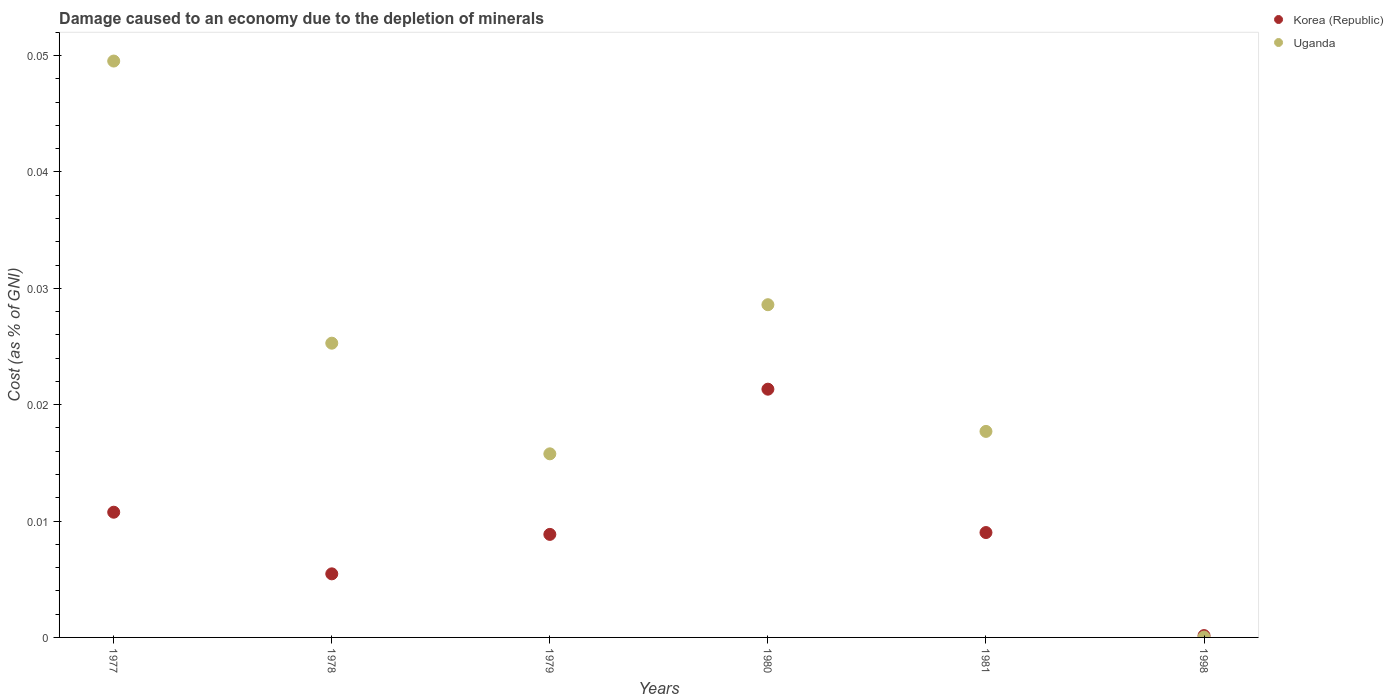What is the cost of damage caused due to the depletion of minerals in Korea (Republic) in 1979?
Offer a terse response. 0.01. Across all years, what is the maximum cost of damage caused due to the depletion of minerals in Uganda?
Your answer should be very brief. 0.05. Across all years, what is the minimum cost of damage caused due to the depletion of minerals in Korea (Republic)?
Make the answer very short. 0. In which year was the cost of damage caused due to the depletion of minerals in Uganda maximum?
Offer a terse response. 1977. What is the total cost of damage caused due to the depletion of minerals in Korea (Republic) in the graph?
Provide a short and direct response. 0.06. What is the difference between the cost of damage caused due to the depletion of minerals in Uganda in 1978 and that in 1979?
Your answer should be compact. 0.01. What is the difference between the cost of damage caused due to the depletion of minerals in Korea (Republic) in 1979 and the cost of damage caused due to the depletion of minerals in Uganda in 1977?
Your response must be concise. -0.04. What is the average cost of damage caused due to the depletion of minerals in Korea (Republic) per year?
Offer a very short reply. 0.01. In the year 1978, what is the difference between the cost of damage caused due to the depletion of minerals in Uganda and cost of damage caused due to the depletion of minerals in Korea (Republic)?
Ensure brevity in your answer.  0.02. What is the ratio of the cost of damage caused due to the depletion of minerals in Korea (Republic) in 1977 to that in 1998?
Provide a short and direct response. 67.77. Is the cost of damage caused due to the depletion of minerals in Uganda in 1981 less than that in 1998?
Make the answer very short. No. Is the difference between the cost of damage caused due to the depletion of minerals in Uganda in 1977 and 1980 greater than the difference between the cost of damage caused due to the depletion of minerals in Korea (Republic) in 1977 and 1980?
Your answer should be compact. Yes. What is the difference between the highest and the second highest cost of damage caused due to the depletion of minerals in Korea (Republic)?
Provide a succinct answer. 0.01. What is the difference between the highest and the lowest cost of damage caused due to the depletion of minerals in Korea (Republic)?
Your response must be concise. 0.02. In how many years, is the cost of damage caused due to the depletion of minerals in Korea (Republic) greater than the average cost of damage caused due to the depletion of minerals in Korea (Republic) taken over all years?
Provide a succinct answer. 2. Does the cost of damage caused due to the depletion of minerals in Korea (Republic) monotonically increase over the years?
Provide a succinct answer. No. Is the cost of damage caused due to the depletion of minerals in Uganda strictly greater than the cost of damage caused due to the depletion of minerals in Korea (Republic) over the years?
Your answer should be compact. No. How many dotlines are there?
Keep it short and to the point. 2. What is the difference between two consecutive major ticks on the Y-axis?
Provide a succinct answer. 0.01. Are the values on the major ticks of Y-axis written in scientific E-notation?
Give a very brief answer. No. Does the graph contain grids?
Offer a very short reply. No. What is the title of the graph?
Offer a terse response. Damage caused to an economy due to the depletion of minerals. What is the label or title of the X-axis?
Provide a succinct answer. Years. What is the label or title of the Y-axis?
Give a very brief answer. Cost (as % of GNI). What is the Cost (as % of GNI) in Korea (Republic) in 1977?
Your response must be concise. 0.01. What is the Cost (as % of GNI) of Uganda in 1977?
Your response must be concise. 0.05. What is the Cost (as % of GNI) of Korea (Republic) in 1978?
Make the answer very short. 0.01. What is the Cost (as % of GNI) of Uganda in 1978?
Make the answer very short. 0.03. What is the Cost (as % of GNI) of Korea (Republic) in 1979?
Ensure brevity in your answer.  0.01. What is the Cost (as % of GNI) in Uganda in 1979?
Your answer should be very brief. 0.02. What is the Cost (as % of GNI) of Korea (Republic) in 1980?
Provide a short and direct response. 0.02. What is the Cost (as % of GNI) in Uganda in 1980?
Offer a very short reply. 0.03. What is the Cost (as % of GNI) of Korea (Republic) in 1981?
Your response must be concise. 0.01. What is the Cost (as % of GNI) in Uganda in 1981?
Offer a very short reply. 0.02. What is the Cost (as % of GNI) of Korea (Republic) in 1998?
Keep it short and to the point. 0. What is the Cost (as % of GNI) in Uganda in 1998?
Your answer should be very brief. 2.98912149947145e-5. Across all years, what is the maximum Cost (as % of GNI) of Korea (Republic)?
Your response must be concise. 0.02. Across all years, what is the maximum Cost (as % of GNI) in Uganda?
Offer a very short reply. 0.05. Across all years, what is the minimum Cost (as % of GNI) in Korea (Republic)?
Offer a terse response. 0. Across all years, what is the minimum Cost (as % of GNI) of Uganda?
Make the answer very short. 2.98912149947145e-5. What is the total Cost (as % of GNI) in Korea (Republic) in the graph?
Keep it short and to the point. 0.06. What is the total Cost (as % of GNI) of Uganda in the graph?
Offer a terse response. 0.14. What is the difference between the Cost (as % of GNI) in Korea (Republic) in 1977 and that in 1978?
Provide a succinct answer. 0.01. What is the difference between the Cost (as % of GNI) in Uganda in 1977 and that in 1978?
Your response must be concise. 0.02. What is the difference between the Cost (as % of GNI) in Korea (Republic) in 1977 and that in 1979?
Offer a very short reply. 0. What is the difference between the Cost (as % of GNI) of Uganda in 1977 and that in 1979?
Provide a succinct answer. 0.03. What is the difference between the Cost (as % of GNI) in Korea (Republic) in 1977 and that in 1980?
Offer a very short reply. -0.01. What is the difference between the Cost (as % of GNI) of Uganda in 1977 and that in 1980?
Make the answer very short. 0.02. What is the difference between the Cost (as % of GNI) of Korea (Republic) in 1977 and that in 1981?
Give a very brief answer. 0. What is the difference between the Cost (as % of GNI) of Uganda in 1977 and that in 1981?
Give a very brief answer. 0.03. What is the difference between the Cost (as % of GNI) in Korea (Republic) in 1977 and that in 1998?
Give a very brief answer. 0.01. What is the difference between the Cost (as % of GNI) of Uganda in 1977 and that in 1998?
Provide a short and direct response. 0.05. What is the difference between the Cost (as % of GNI) of Korea (Republic) in 1978 and that in 1979?
Provide a short and direct response. -0. What is the difference between the Cost (as % of GNI) of Uganda in 1978 and that in 1979?
Keep it short and to the point. 0.01. What is the difference between the Cost (as % of GNI) in Korea (Republic) in 1978 and that in 1980?
Make the answer very short. -0.02. What is the difference between the Cost (as % of GNI) in Uganda in 1978 and that in 1980?
Ensure brevity in your answer.  -0. What is the difference between the Cost (as % of GNI) of Korea (Republic) in 1978 and that in 1981?
Ensure brevity in your answer.  -0. What is the difference between the Cost (as % of GNI) in Uganda in 1978 and that in 1981?
Your answer should be very brief. 0.01. What is the difference between the Cost (as % of GNI) in Korea (Republic) in 1978 and that in 1998?
Give a very brief answer. 0.01. What is the difference between the Cost (as % of GNI) of Uganda in 1978 and that in 1998?
Offer a terse response. 0.03. What is the difference between the Cost (as % of GNI) in Korea (Republic) in 1979 and that in 1980?
Make the answer very short. -0.01. What is the difference between the Cost (as % of GNI) of Uganda in 1979 and that in 1980?
Offer a terse response. -0.01. What is the difference between the Cost (as % of GNI) in Korea (Republic) in 1979 and that in 1981?
Make the answer very short. -0. What is the difference between the Cost (as % of GNI) of Uganda in 1979 and that in 1981?
Give a very brief answer. -0. What is the difference between the Cost (as % of GNI) in Korea (Republic) in 1979 and that in 1998?
Your answer should be compact. 0.01. What is the difference between the Cost (as % of GNI) of Uganda in 1979 and that in 1998?
Offer a very short reply. 0.02. What is the difference between the Cost (as % of GNI) in Korea (Republic) in 1980 and that in 1981?
Provide a succinct answer. 0.01. What is the difference between the Cost (as % of GNI) in Uganda in 1980 and that in 1981?
Your answer should be very brief. 0.01. What is the difference between the Cost (as % of GNI) in Korea (Republic) in 1980 and that in 1998?
Ensure brevity in your answer.  0.02. What is the difference between the Cost (as % of GNI) in Uganda in 1980 and that in 1998?
Provide a succinct answer. 0.03. What is the difference between the Cost (as % of GNI) of Korea (Republic) in 1981 and that in 1998?
Make the answer very short. 0.01. What is the difference between the Cost (as % of GNI) in Uganda in 1981 and that in 1998?
Offer a terse response. 0.02. What is the difference between the Cost (as % of GNI) in Korea (Republic) in 1977 and the Cost (as % of GNI) in Uganda in 1978?
Provide a succinct answer. -0.01. What is the difference between the Cost (as % of GNI) in Korea (Republic) in 1977 and the Cost (as % of GNI) in Uganda in 1979?
Make the answer very short. -0.01. What is the difference between the Cost (as % of GNI) in Korea (Republic) in 1977 and the Cost (as % of GNI) in Uganda in 1980?
Keep it short and to the point. -0.02. What is the difference between the Cost (as % of GNI) in Korea (Republic) in 1977 and the Cost (as % of GNI) in Uganda in 1981?
Ensure brevity in your answer.  -0.01. What is the difference between the Cost (as % of GNI) of Korea (Republic) in 1977 and the Cost (as % of GNI) of Uganda in 1998?
Provide a short and direct response. 0.01. What is the difference between the Cost (as % of GNI) in Korea (Republic) in 1978 and the Cost (as % of GNI) in Uganda in 1979?
Provide a succinct answer. -0.01. What is the difference between the Cost (as % of GNI) of Korea (Republic) in 1978 and the Cost (as % of GNI) of Uganda in 1980?
Your answer should be very brief. -0.02. What is the difference between the Cost (as % of GNI) in Korea (Republic) in 1978 and the Cost (as % of GNI) in Uganda in 1981?
Your answer should be very brief. -0.01. What is the difference between the Cost (as % of GNI) of Korea (Republic) in 1978 and the Cost (as % of GNI) of Uganda in 1998?
Give a very brief answer. 0.01. What is the difference between the Cost (as % of GNI) in Korea (Republic) in 1979 and the Cost (as % of GNI) in Uganda in 1980?
Your answer should be compact. -0.02. What is the difference between the Cost (as % of GNI) of Korea (Republic) in 1979 and the Cost (as % of GNI) of Uganda in 1981?
Offer a terse response. -0.01. What is the difference between the Cost (as % of GNI) in Korea (Republic) in 1979 and the Cost (as % of GNI) in Uganda in 1998?
Your response must be concise. 0.01. What is the difference between the Cost (as % of GNI) of Korea (Republic) in 1980 and the Cost (as % of GNI) of Uganda in 1981?
Offer a very short reply. 0. What is the difference between the Cost (as % of GNI) of Korea (Republic) in 1980 and the Cost (as % of GNI) of Uganda in 1998?
Your answer should be very brief. 0.02. What is the difference between the Cost (as % of GNI) of Korea (Republic) in 1981 and the Cost (as % of GNI) of Uganda in 1998?
Your response must be concise. 0.01. What is the average Cost (as % of GNI) in Korea (Republic) per year?
Give a very brief answer. 0.01. What is the average Cost (as % of GNI) in Uganda per year?
Provide a succinct answer. 0.02. In the year 1977, what is the difference between the Cost (as % of GNI) of Korea (Republic) and Cost (as % of GNI) of Uganda?
Provide a succinct answer. -0.04. In the year 1978, what is the difference between the Cost (as % of GNI) of Korea (Republic) and Cost (as % of GNI) of Uganda?
Your response must be concise. -0.02. In the year 1979, what is the difference between the Cost (as % of GNI) of Korea (Republic) and Cost (as % of GNI) of Uganda?
Your answer should be compact. -0.01. In the year 1980, what is the difference between the Cost (as % of GNI) in Korea (Republic) and Cost (as % of GNI) in Uganda?
Provide a short and direct response. -0.01. In the year 1981, what is the difference between the Cost (as % of GNI) in Korea (Republic) and Cost (as % of GNI) in Uganda?
Give a very brief answer. -0.01. In the year 1998, what is the difference between the Cost (as % of GNI) of Korea (Republic) and Cost (as % of GNI) of Uganda?
Your answer should be very brief. 0. What is the ratio of the Cost (as % of GNI) in Korea (Republic) in 1977 to that in 1978?
Your response must be concise. 1.97. What is the ratio of the Cost (as % of GNI) in Uganda in 1977 to that in 1978?
Give a very brief answer. 1.96. What is the ratio of the Cost (as % of GNI) in Korea (Republic) in 1977 to that in 1979?
Offer a very short reply. 1.22. What is the ratio of the Cost (as % of GNI) in Uganda in 1977 to that in 1979?
Give a very brief answer. 3.14. What is the ratio of the Cost (as % of GNI) of Korea (Republic) in 1977 to that in 1980?
Your answer should be very brief. 0.5. What is the ratio of the Cost (as % of GNI) in Uganda in 1977 to that in 1980?
Provide a succinct answer. 1.73. What is the ratio of the Cost (as % of GNI) in Korea (Republic) in 1977 to that in 1981?
Make the answer very short. 1.19. What is the ratio of the Cost (as % of GNI) in Uganda in 1977 to that in 1981?
Provide a succinct answer. 2.8. What is the ratio of the Cost (as % of GNI) of Korea (Republic) in 1977 to that in 1998?
Provide a short and direct response. 67.77. What is the ratio of the Cost (as % of GNI) in Uganda in 1977 to that in 1998?
Make the answer very short. 1657.15. What is the ratio of the Cost (as % of GNI) of Korea (Republic) in 1978 to that in 1979?
Offer a terse response. 0.62. What is the ratio of the Cost (as % of GNI) in Uganda in 1978 to that in 1979?
Provide a short and direct response. 1.6. What is the ratio of the Cost (as % of GNI) of Korea (Republic) in 1978 to that in 1980?
Give a very brief answer. 0.26. What is the ratio of the Cost (as % of GNI) of Uganda in 1978 to that in 1980?
Provide a succinct answer. 0.88. What is the ratio of the Cost (as % of GNI) in Korea (Republic) in 1978 to that in 1981?
Your answer should be very brief. 0.61. What is the ratio of the Cost (as % of GNI) in Uganda in 1978 to that in 1981?
Your answer should be very brief. 1.43. What is the ratio of the Cost (as % of GNI) of Korea (Republic) in 1978 to that in 1998?
Your answer should be compact. 34.41. What is the ratio of the Cost (as % of GNI) of Uganda in 1978 to that in 1998?
Your answer should be compact. 845.98. What is the ratio of the Cost (as % of GNI) in Korea (Republic) in 1979 to that in 1980?
Keep it short and to the point. 0.41. What is the ratio of the Cost (as % of GNI) in Uganda in 1979 to that in 1980?
Make the answer very short. 0.55. What is the ratio of the Cost (as % of GNI) of Korea (Republic) in 1979 to that in 1981?
Provide a short and direct response. 0.98. What is the ratio of the Cost (as % of GNI) in Uganda in 1979 to that in 1981?
Offer a very short reply. 0.89. What is the ratio of the Cost (as % of GNI) of Korea (Republic) in 1979 to that in 1998?
Ensure brevity in your answer.  55.77. What is the ratio of the Cost (as % of GNI) in Uganda in 1979 to that in 1998?
Give a very brief answer. 527.86. What is the ratio of the Cost (as % of GNI) in Korea (Republic) in 1980 to that in 1981?
Provide a succinct answer. 2.37. What is the ratio of the Cost (as % of GNI) of Uganda in 1980 to that in 1981?
Offer a very short reply. 1.61. What is the ratio of the Cost (as % of GNI) of Korea (Republic) in 1980 to that in 1998?
Ensure brevity in your answer.  134.36. What is the ratio of the Cost (as % of GNI) of Uganda in 1980 to that in 1998?
Your answer should be compact. 956.61. What is the ratio of the Cost (as % of GNI) of Korea (Republic) in 1981 to that in 1998?
Your response must be concise. 56.77. What is the ratio of the Cost (as % of GNI) in Uganda in 1981 to that in 1998?
Your answer should be very brief. 592.33. What is the difference between the highest and the second highest Cost (as % of GNI) of Korea (Republic)?
Give a very brief answer. 0.01. What is the difference between the highest and the second highest Cost (as % of GNI) in Uganda?
Give a very brief answer. 0.02. What is the difference between the highest and the lowest Cost (as % of GNI) of Korea (Republic)?
Your answer should be very brief. 0.02. What is the difference between the highest and the lowest Cost (as % of GNI) of Uganda?
Your answer should be compact. 0.05. 